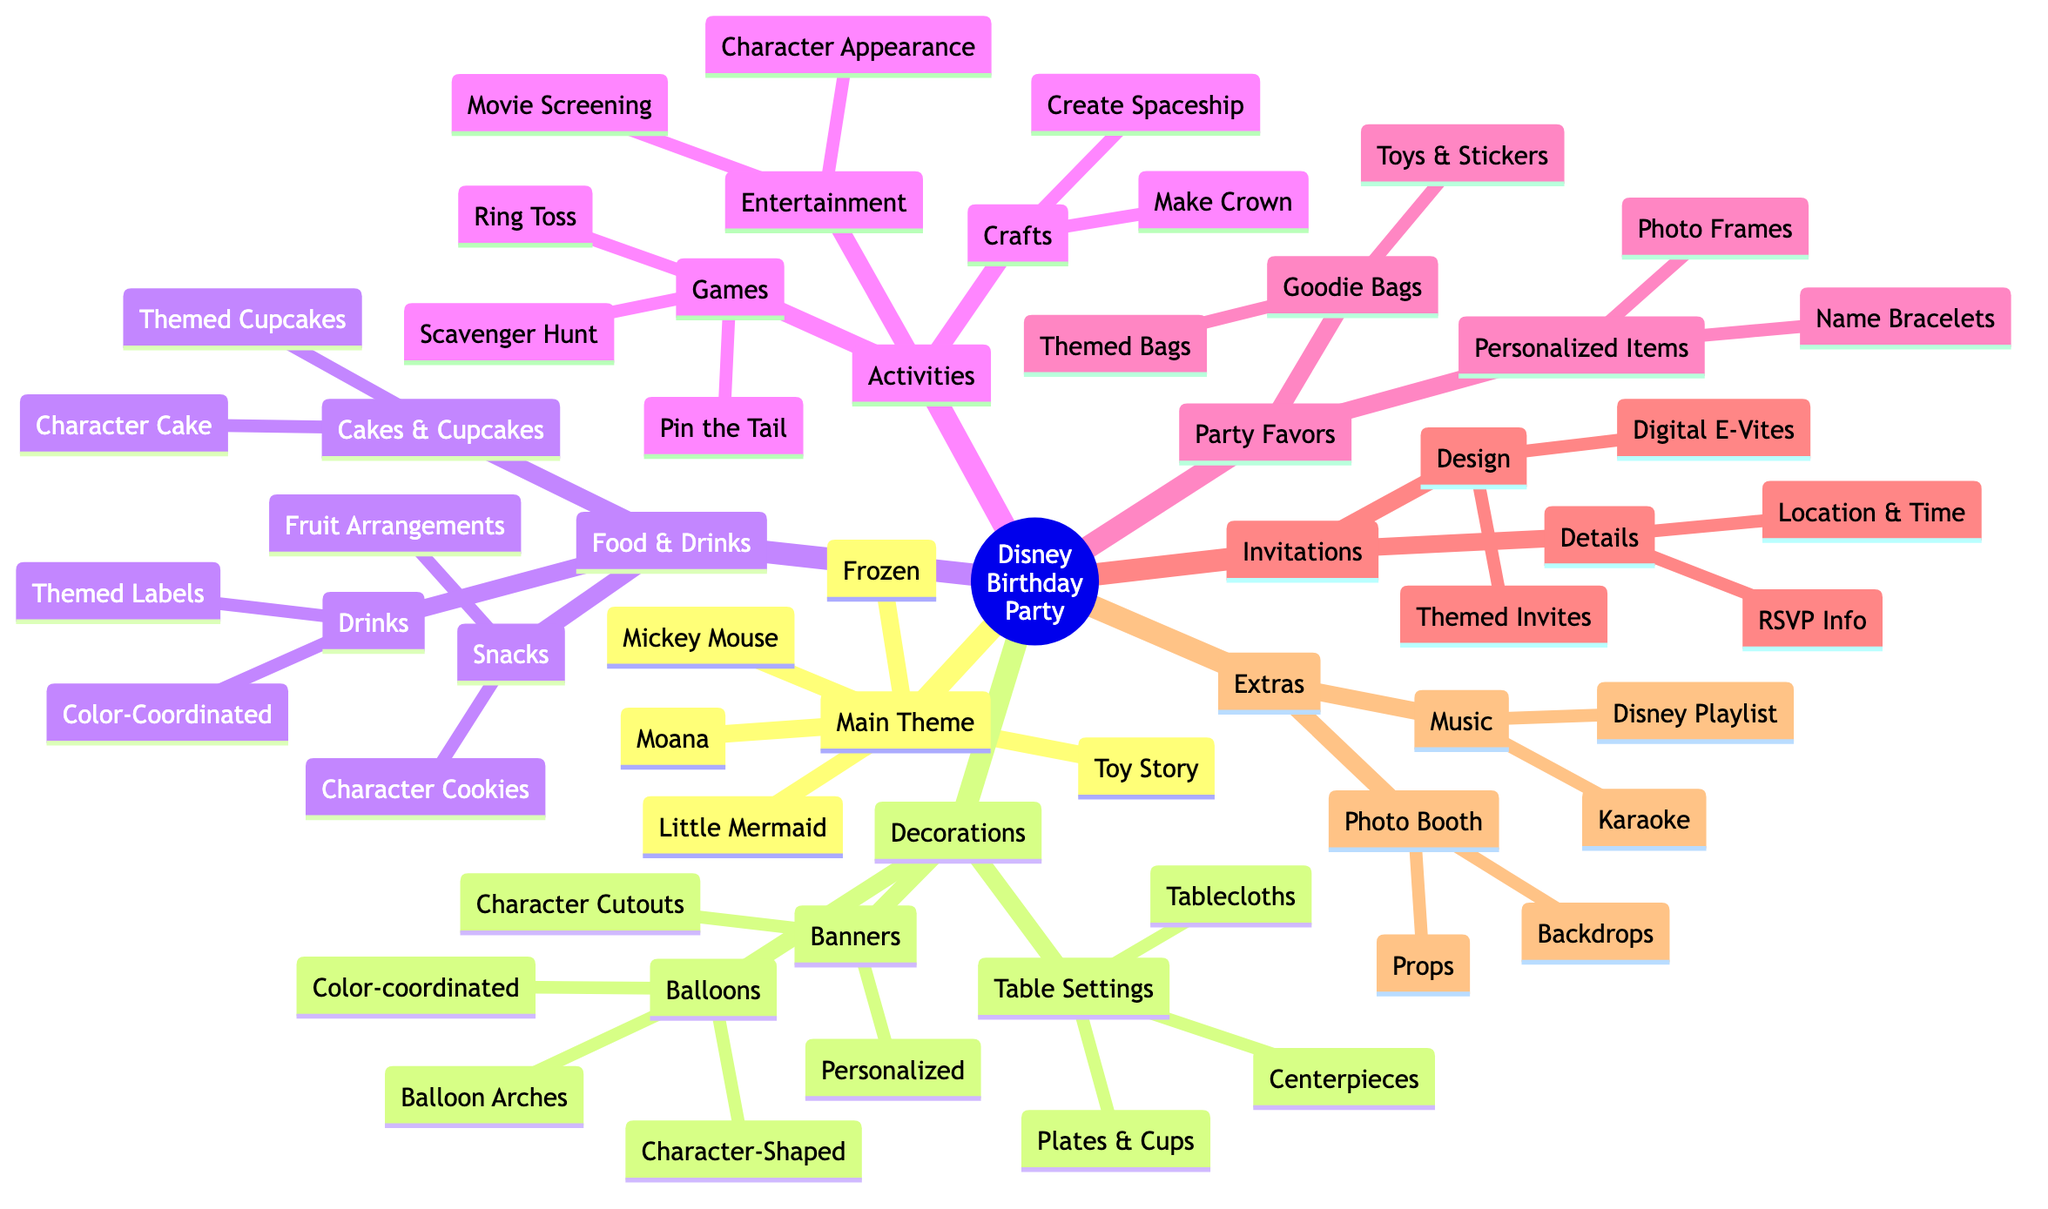What are the character options for the main theme? The main theme section lists five character options which are Mickey Mouse, Frozen (Elsa and Anna), Toy Story (Woody and Buzz Lightyear), Moana, and The Little Mermaid (Ariel).
Answer: Mickey Mouse, Frozen, Toy Story, Moana, Little Mermaid How many different types of decorations are listed? In the decorations section, there are three main categories: Balloons, Banners, and Table Settings. Each category contains various options, but the number of categories is what is asked for.
Answer: 3 What snacks are categorized under food and drinks? The snacks listed under food and drinks include Character-Shaped Cookies and Fruit Arrangements (Fruit Characters), which fall under the 'Snacks' category.
Answer: Character-Shaped Cookies, Fruit Arrangements What activities are offered for entertainment? The activities section provides two types of entertainment: Character Appearance (Hire Professional or Costume) and Disney Movie Screening. Both will provide entertainment for guests at the party.
Answer: Character Appearance, Movie Screening Which type of music is included in extras? Under the extras category, two types of music options are provided: Disney Playlist and Karaoke with Disney Songs. These will add a fun musical element to the party.
Answer: Disney Playlist, Karaoke How are the invitations designed? The invitations are categorized into two designs: Character-Themed Invitations and Digital E-Vites. This shows that there are options for how invitations can be made or sent.
Answer: Character-Themed Invitations, Digital E-Vites What are the contents of the goodie bags? The goodie bags section includes Character-Themed Goodie Bags and Toys & Stickers, which are both described as items included in the goodie bags given out at the party.
Answer: Character-Themed Goodie Bags, Toys & Stickers What types of crafts are available for activities? The crafts section mentions two options: Make Your Own Crown (Frozen) and Create Your Own Spaceship (Toy Story), making them the available craft activities for the party.
Answer: Make Your Own Crown, Create Your Own Spaceship How many games are listed under activities? Within the games section, three games are specified: Pin the Tail on Eeyore, Frozen-Themed Scavenger Hunt, and Toy Story Ring Toss, totaling three different games available for the party.
Answer: 3 